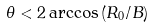<formula> <loc_0><loc_0><loc_500><loc_500>\theta < 2 \arccos \left ( R _ { 0 } / B \right )</formula> 